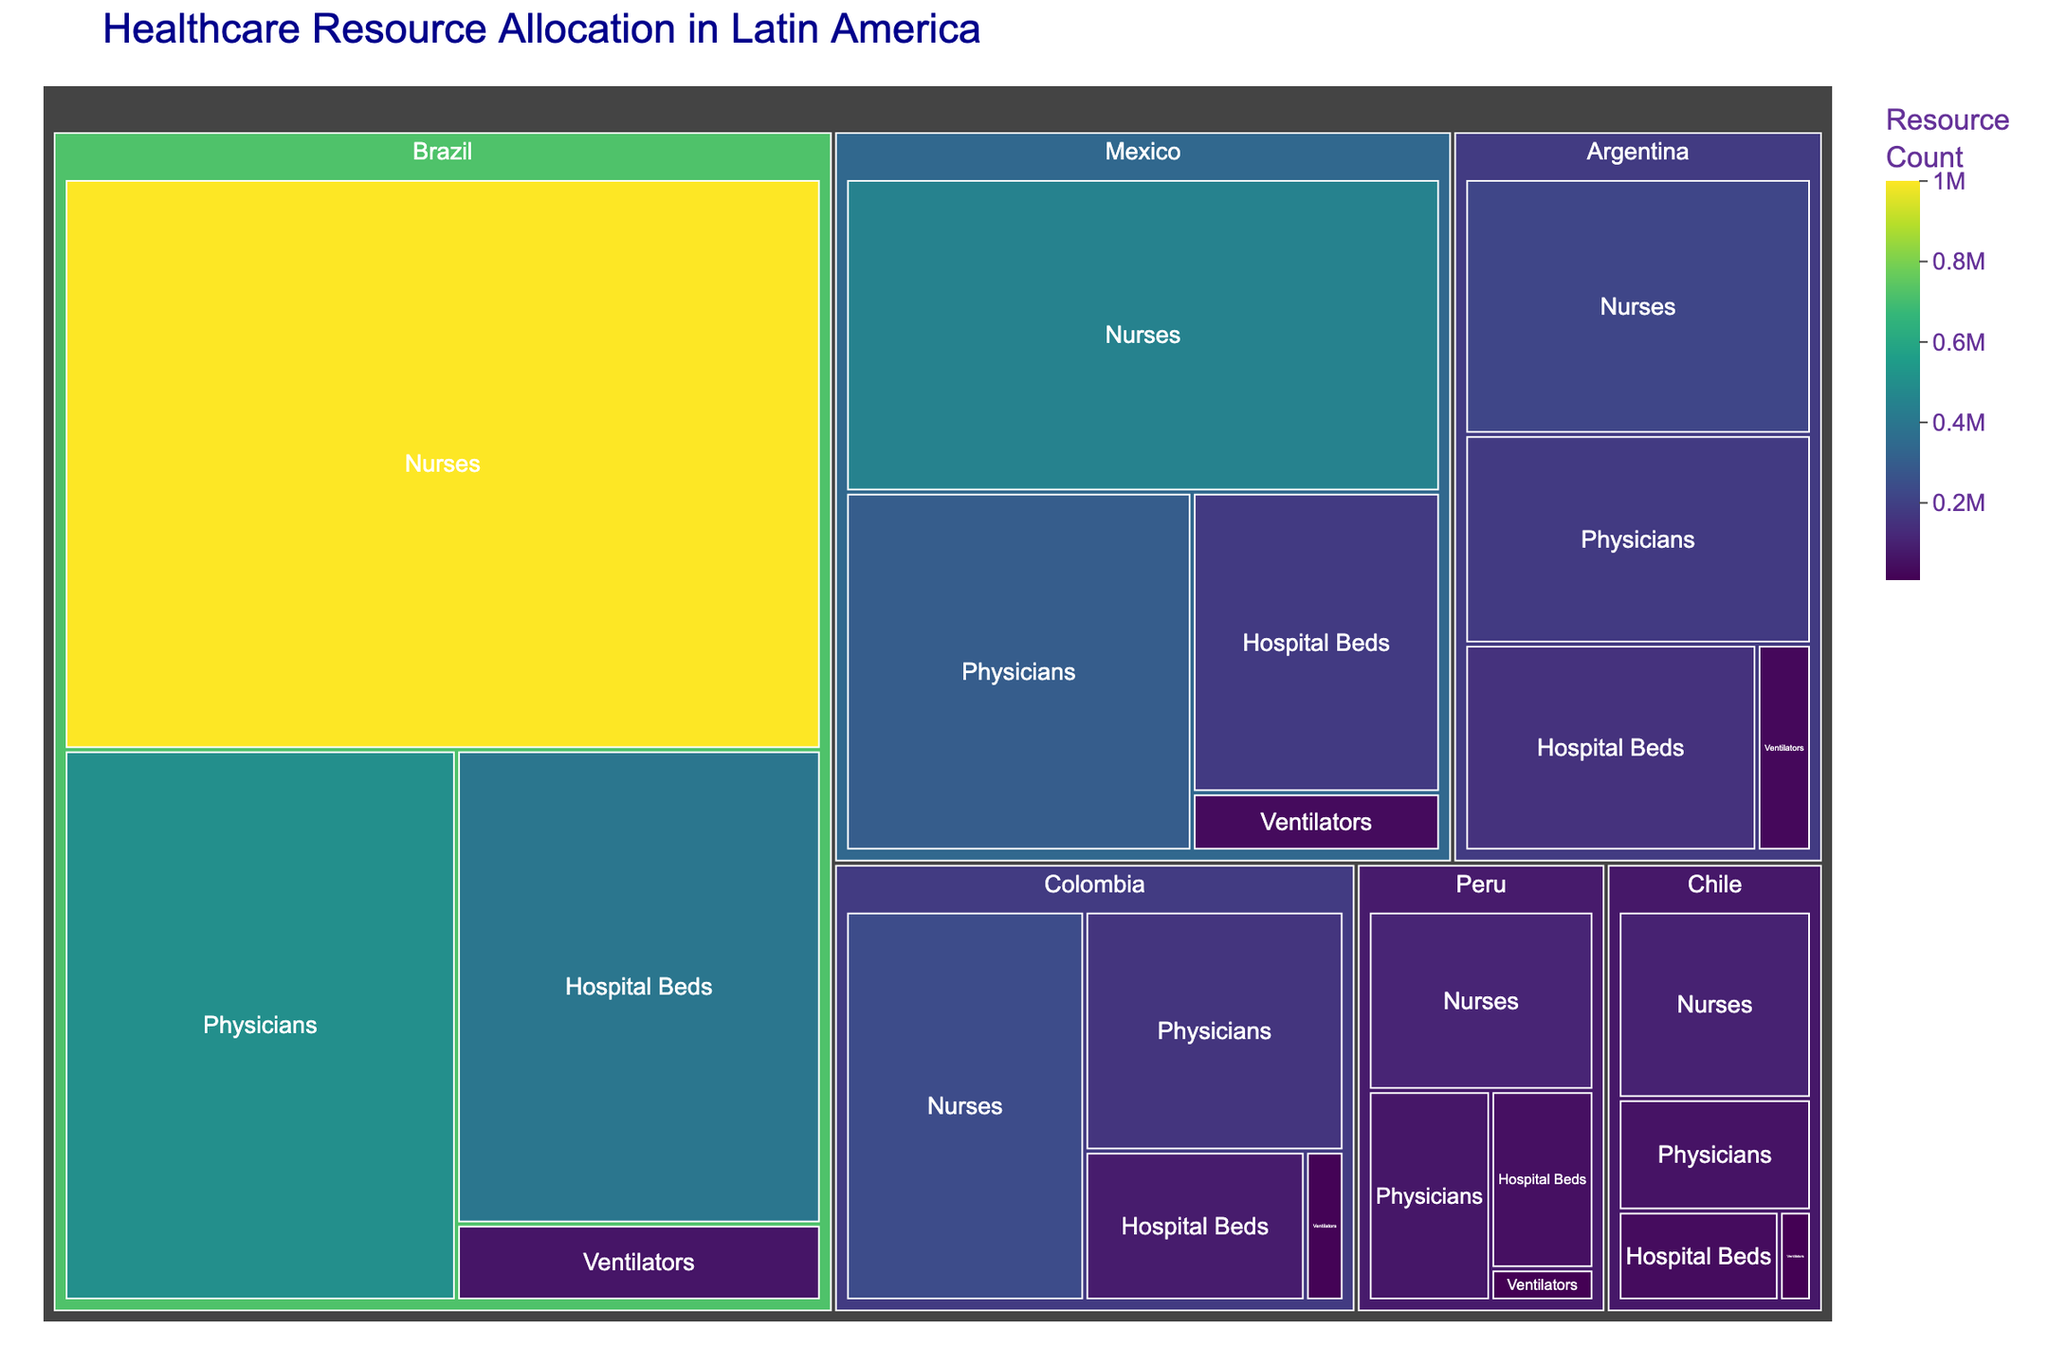What's the title of the treemap? The title of the plot is usually placed at the top center. In this case, it reads "Healthcare Resource Allocation in Latin America".
Answer: Healthcare Resource Allocation in Latin America Which country has the highest number of nurses? By examining the treemap, we can see that Brazil has the largest area allocated to the "Nurses" resource type, indicating the highest value.
Answer: Brazil How many ventilators are allocated in Chile? The size of the tile and the hover data will provide this information. Hovering over the Chile tile under "Ventilators" shows the value as 8,000.
Answer: 8,000 What is the total number of hospital beds in Brazil and Mexico combined? Adding the values for hospital beds in Brazil (400,000) and Mexico (180,000) gives the total. The sum is 400,000 + 180,000 = 580,000.
Answer: 580,000 Which resource type is the largest in terms of count for Colombia? By looking at the allocation for Colombia, "Nurses" has the largest area, indicating the highest count for Colombia.
Answer: Nurses Compare the number of physicians between Argentina and Peru. Which country has more, and by how many? Argentina has 180,000 physicians, and Peru has 70,000. Subtracting these, 180,000 - 70,000 = 110,000 more physicians in Argentina.
Answer: Argentina, 110,000 more How does the number of hospital beds in Peru compare to that in Chile? Peru has 50,000 hospital beds and Chile has 40,000. Peru has 10,000 more hospital beds than Chile.
Answer: Peru has 10,000 more What is the average number of ventilators across all the countries listed? Sum the ventilators across all countries (65,000 + 35,000 + 15,000 + 28,000 + 8,000 + 9,000) which equals 160,000. There are 6 countries, so 160,000 / 6 = 26,667.
Answer: 26,667 Which country has the least amount of healthcare resources combined, and what is the total value? By adding all resource values for each country and comparing, Chile has the least with a total of (40,000 + 60,000 + 100,000 + 8,000) = 208,000.
Answer: Chile, 208,000 